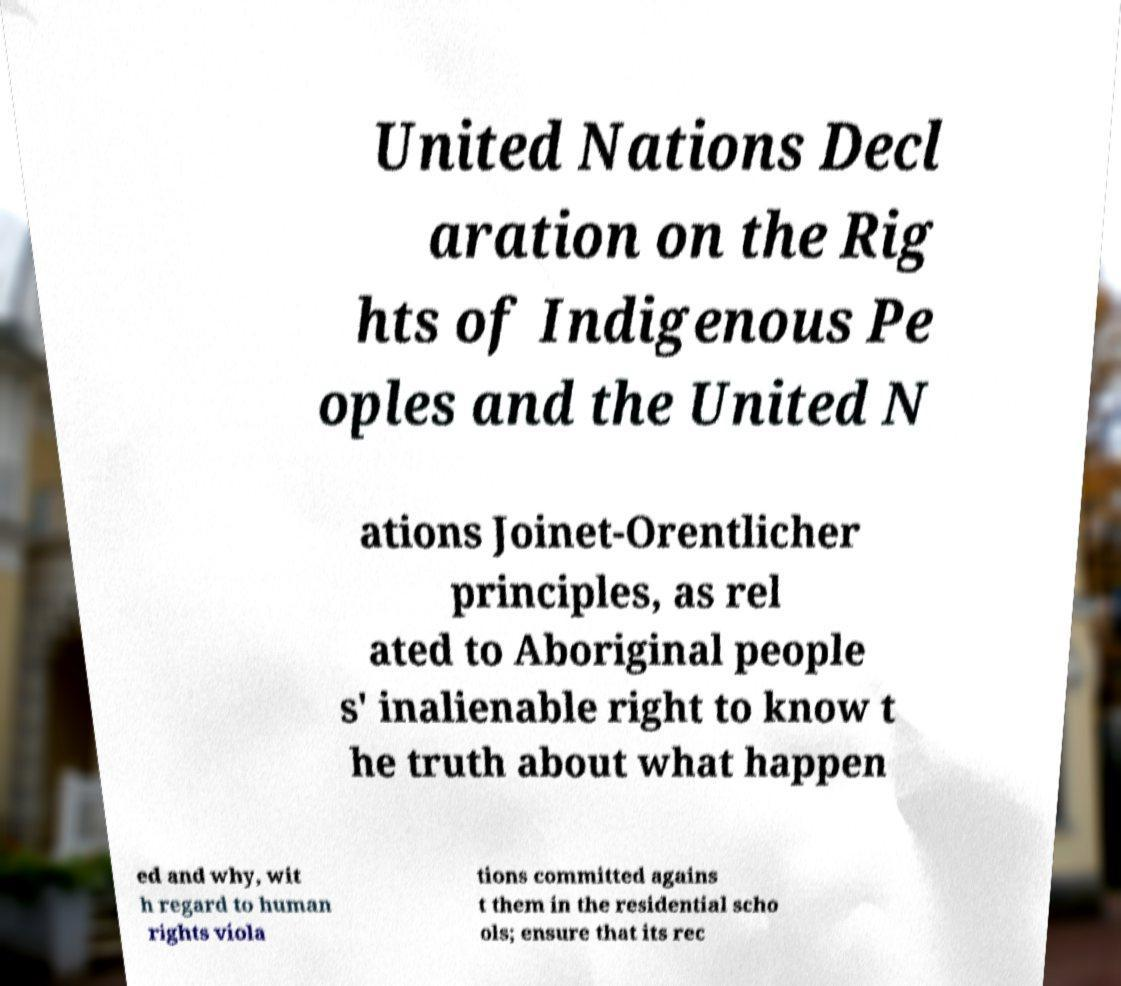Please read and relay the text visible in this image. What does it say? United Nations Decl aration on the Rig hts of Indigenous Pe oples and the United N ations Joinet-Orentlicher principles, as rel ated to Aboriginal people s' inalienable right to know t he truth about what happen ed and why, wit h regard to human rights viola tions committed agains t them in the residential scho ols; ensure that its rec 